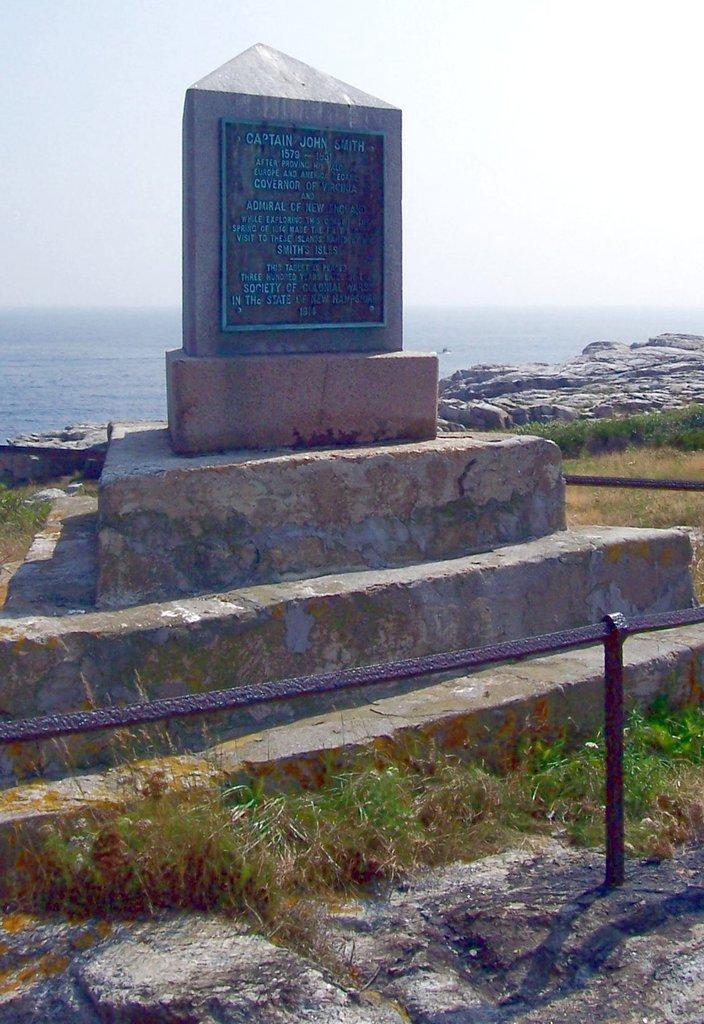In one or two sentences, can you explain what this image depicts? At the bottom of the picture, we see the grass and the rock. We see the iron fence. In the middle of the picture, we see the memorial and the stairs. In the background, we see the rock and water. This water might be in the river. At the top, we see the sky. 